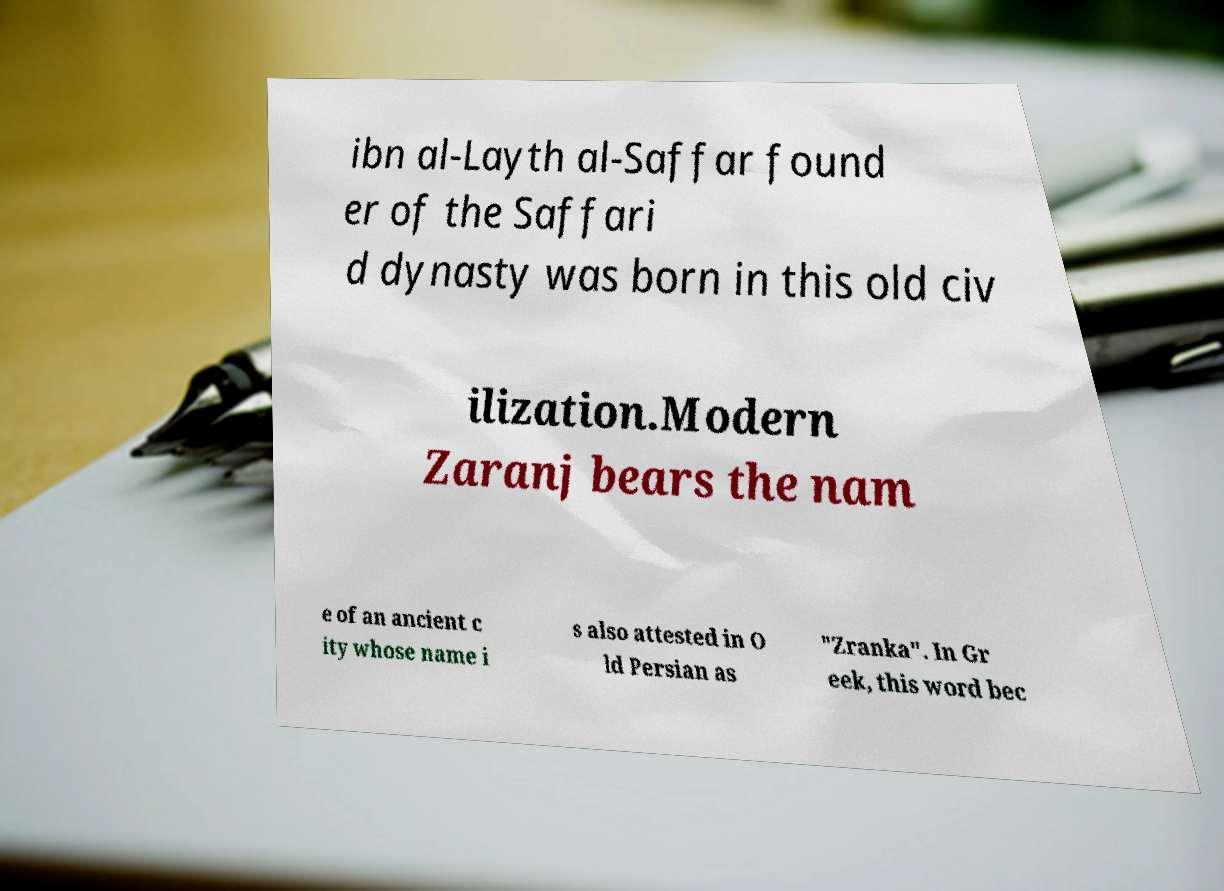Could you extract and type out the text from this image? ibn al-Layth al-Saffar found er of the Saffari d dynasty was born in this old civ ilization.Modern Zaranj bears the nam e of an ancient c ity whose name i s also attested in O ld Persian as "Zranka". In Gr eek, this word bec 